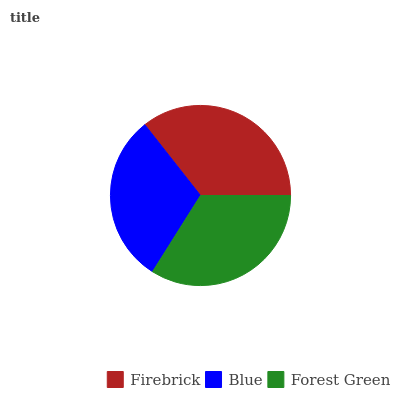Is Blue the minimum?
Answer yes or no. Yes. Is Firebrick the maximum?
Answer yes or no. Yes. Is Forest Green the minimum?
Answer yes or no. No. Is Forest Green the maximum?
Answer yes or no. No. Is Forest Green greater than Blue?
Answer yes or no. Yes. Is Blue less than Forest Green?
Answer yes or no. Yes. Is Blue greater than Forest Green?
Answer yes or no. No. Is Forest Green less than Blue?
Answer yes or no. No. Is Forest Green the high median?
Answer yes or no. Yes. Is Forest Green the low median?
Answer yes or no. Yes. Is Firebrick the high median?
Answer yes or no. No. Is Firebrick the low median?
Answer yes or no. No. 